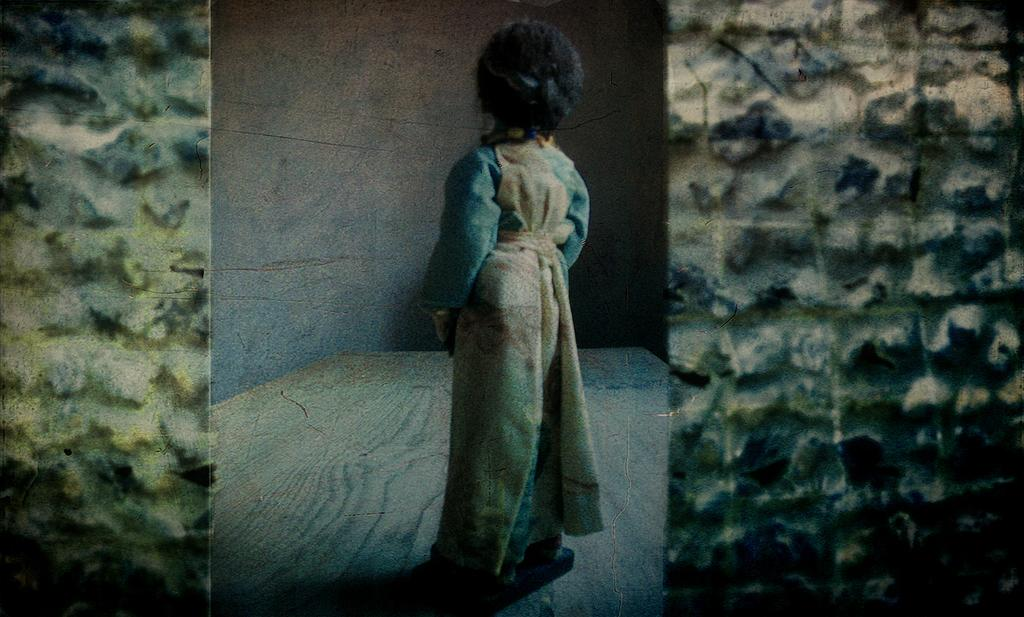What is placed on the floor and wall in the image? There is a person's status on the floor and wall in the image. Where was the image taken? The image was taken in a hall. What type of land or sand can be seen in the image? There is no land or sand present in the image; it features a person's status on the floor and wall in a hall. 